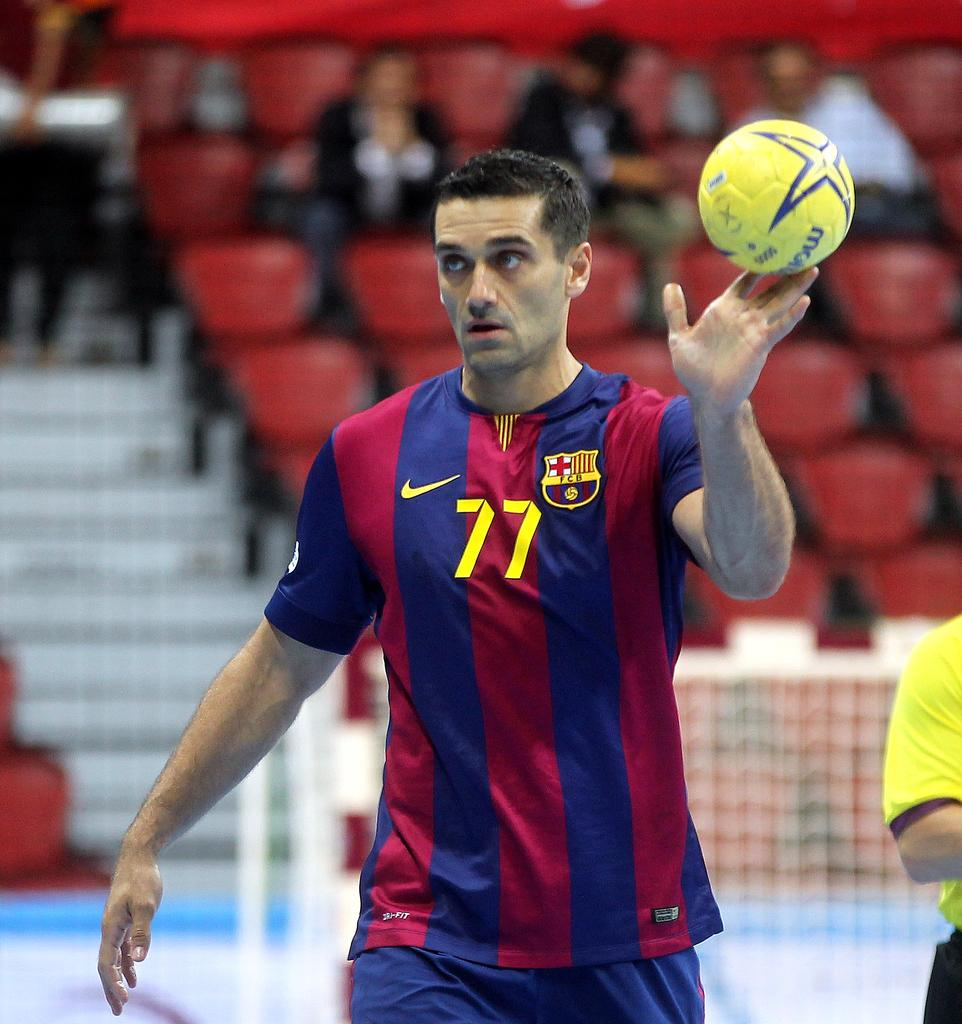Who is present in the image? There is a man in the image. What object can be seen in the image? There is a ball in the image. What can be seen in the background of the image? There are persons sitting on chairs in the background of the image. How many sisters does the man have in the image? There is no information about the man's sisters in the image. What type of person is the man in the image? The image does not provide information about the man's occupation or status, so we cannot determine if he is an actor or any other type of person. 